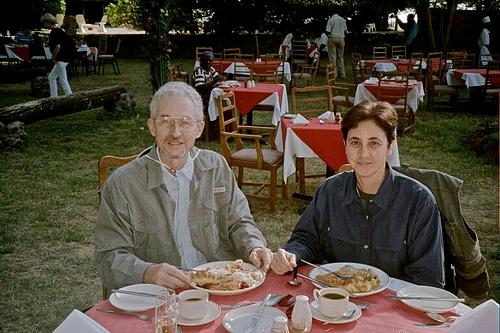Briefly summarize the contents of this image, including the people and their surroundings. A man and woman are enjoying an outdoor breakfast, sitting at a table with red and white tablecloths, and surrounded by wooden chairs, white china plates, coffee cups, and various food items. For the VQA task, what type of outfits are the man and woman wearing? The man is wearing glasses and the woman is wearing a dark blue shirt. Both individuals have a casual and comfortable appearance. In your own words, describe the general scene, including the people and their actions. Two individuals are having a meal outdoors, seated at a table with colorful tablecloths. They are enjoying breakfast from white plates, and drinking coffee from cups placed on saucers. In a product advertisement task, describe the appeal of the displayed food items. The food items on display, including a plate full of delicious breakfast items, make for an enticing and enjoyable outdoor dining experience. What can be said about the dining setup in this product advertisement task? The dining setup showcases an enjoyable outdoor meal with elegant white china plates, cups, and various food items, all set upon a table with red and white tablecloths. What is the primary focus of this image for a multi-choice VQA task? The primary focus of this image is two people enjoying an outdoor breakfast together, with a focus on the table setting and various food items displayed. For the visual entailment task, describe the relationship between the man and woman in the image. The man and woman could possibly be a couple, friends, or even family members, as they are enjoying a meal together in an outdoor setting. What items indicate that the setting of the image is outdoors for a visual entailment task? The presence of wooden chairs on grass, people walking across the lawn, and the overall outdoor venue of tables and chairs suggest an outdoor setting. 